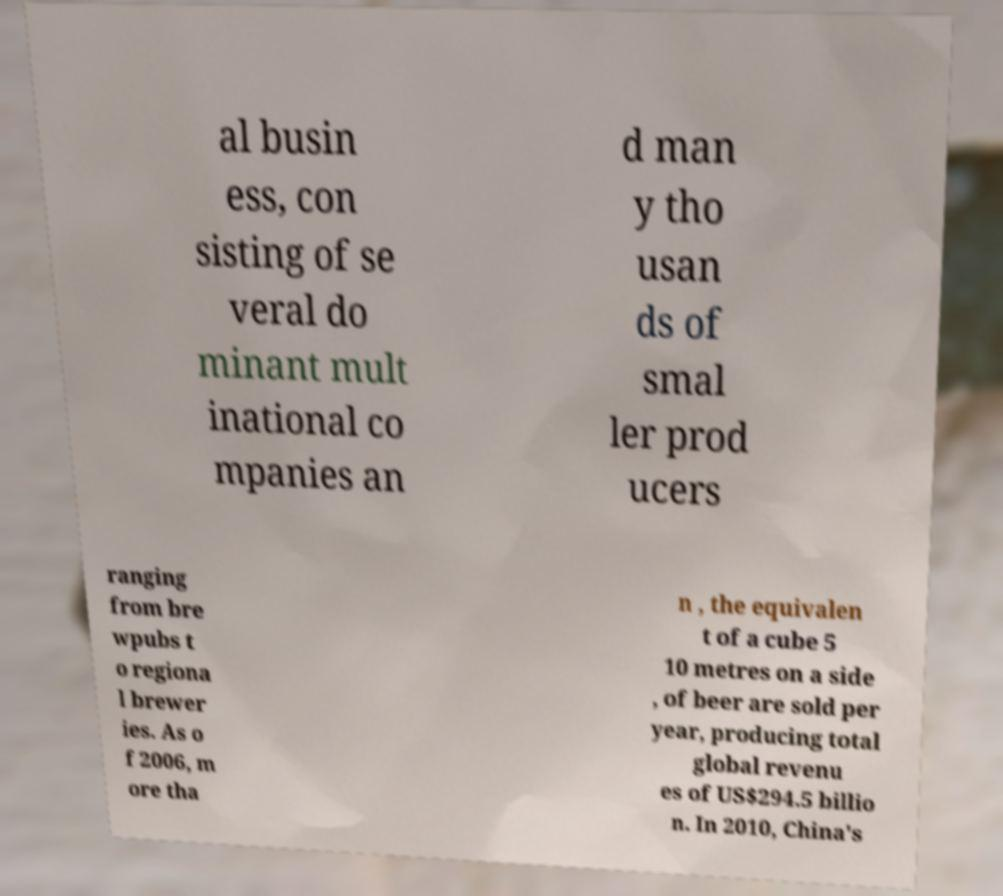For documentation purposes, I need the text within this image transcribed. Could you provide that? al busin ess, con sisting of se veral do minant mult inational co mpanies an d man y tho usan ds of smal ler prod ucers ranging from bre wpubs t o regiona l brewer ies. As o f 2006, m ore tha n , the equivalen t of a cube 5 10 metres on a side , of beer are sold per year, producing total global revenu es of US$294.5 billio n. In 2010, China's 